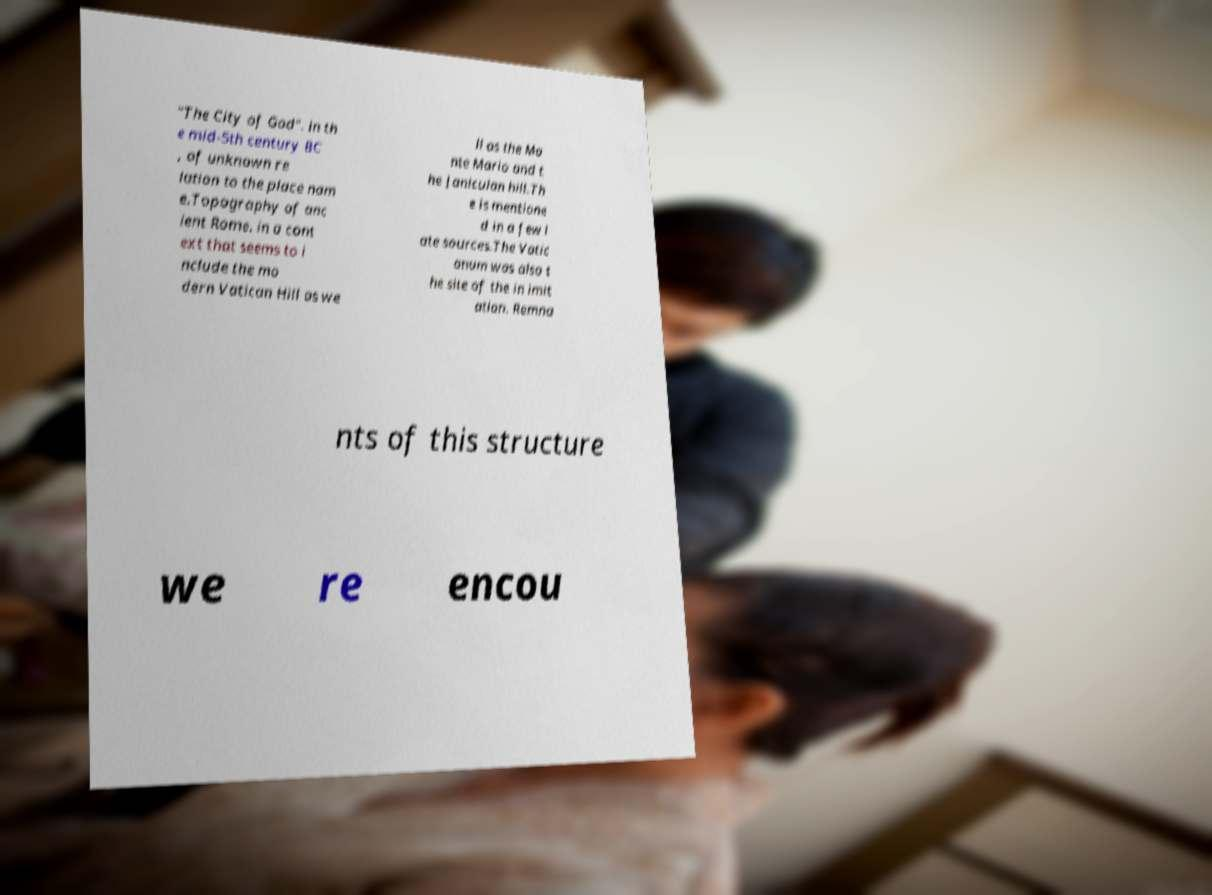Can you accurately transcribe the text from the provided image for me? "The City of God". in th e mid-5th century BC , of unknown re lation to the place nam e.Topography of anc ient Rome. in a cont ext that seems to i nclude the mo dern Vatican Hill as we ll as the Mo nte Mario and t he Janiculan hill.Th e is mentione d in a few l ate sources.The Vatic anum was also t he site of the in imit ation. Remna nts of this structure we re encou 